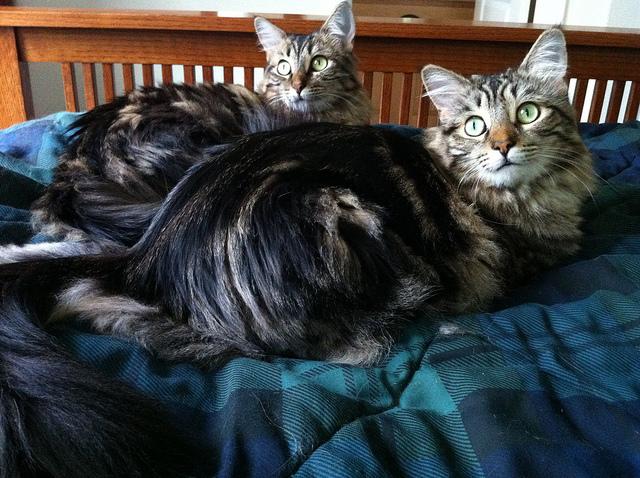Are these cats allowed on the bed?
Keep it brief. Yes. What are the cats lying on?
Quick response, please. Bed. How many pair of eyes do you see?
Answer briefly. 2. 